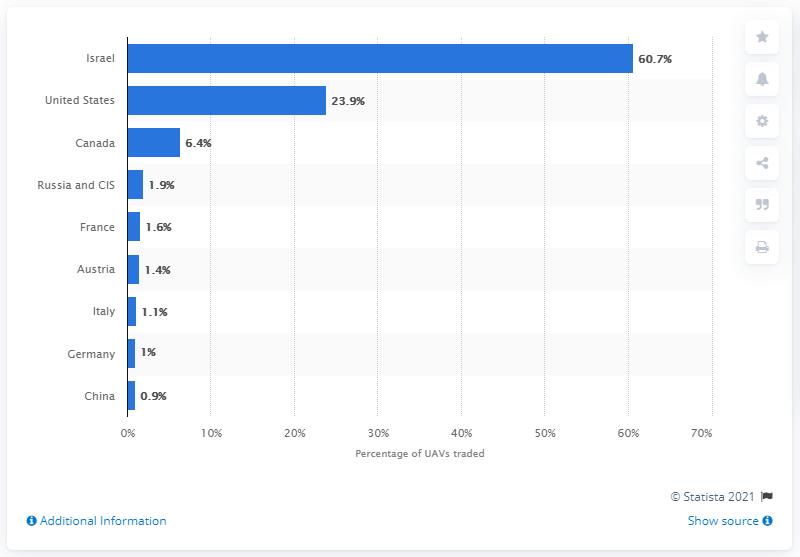Draw attention to some important aspects in this diagram. Approximately 60.7% of all unmanned aerial vehicles (UAVs) traded between 2010 and 2014 were supplied by Israel. 